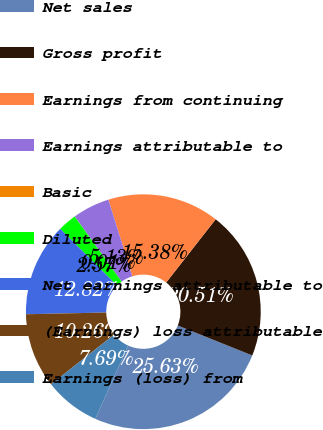Convert chart. <chart><loc_0><loc_0><loc_500><loc_500><pie_chart><fcel>Net sales<fcel>Gross profit<fcel>Earnings from continuing<fcel>Earnings attributable to<fcel>Basic<fcel>Diluted<fcel>Net earnings attributable to<fcel>(Earnings) loss attributable<fcel>Earnings (loss) from<nl><fcel>25.63%<fcel>20.51%<fcel>15.38%<fcel>5.13%<fcel>0.01%<fcel>2.57%<fcel>12.82%<fcel>10.26%<fcel>7.69%<nl></chart> 